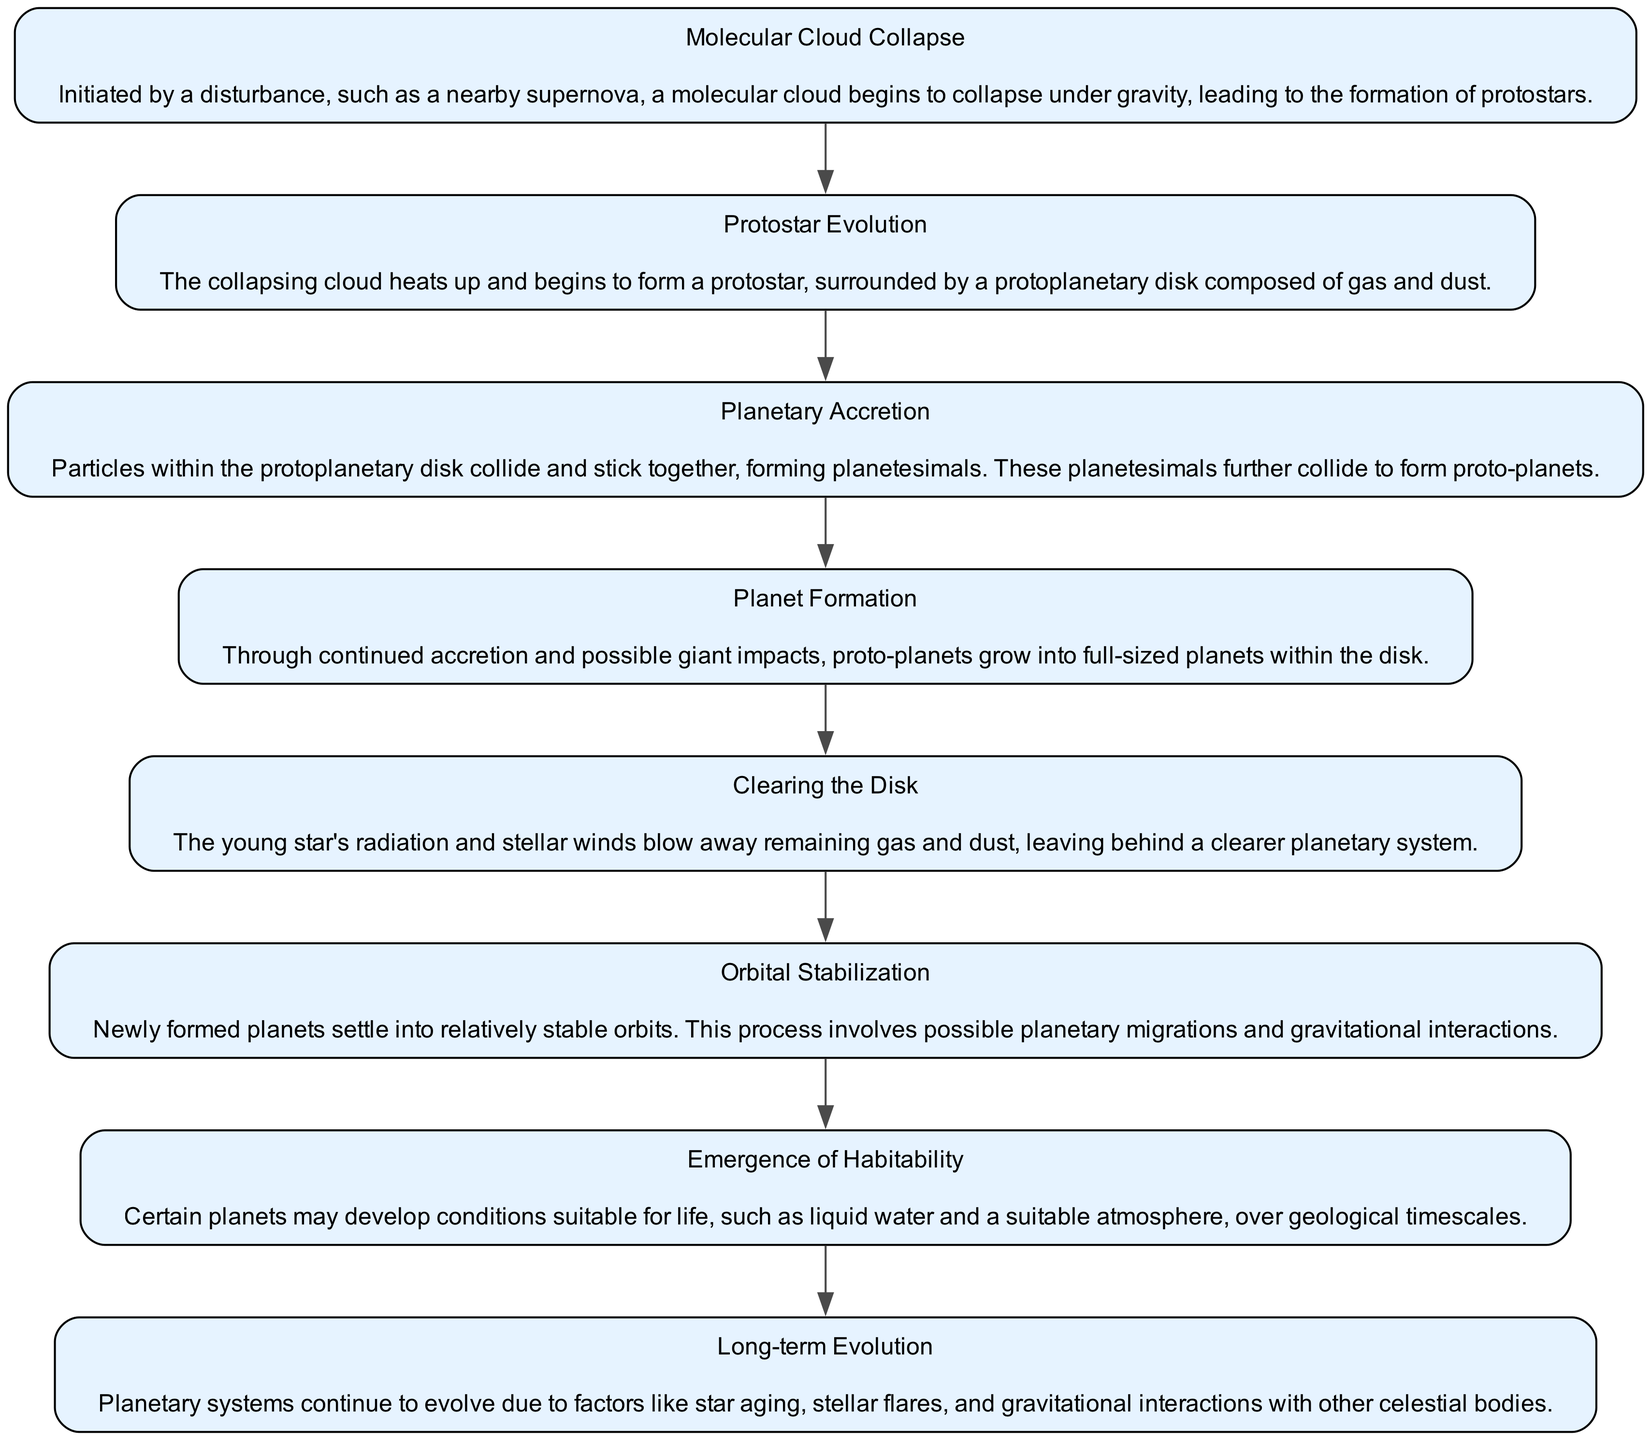What is the first step in the lifecycle of a planetary system? The first step in the lifecycle is "Molecular Cloud Collapse", which is initiated by a disturbance leading to the formation of protostars.
Answer: Molecular Cloud Collapse How many nodes are there in the diagram? Counting all the steps from "Molecular Cloud Collapse" to "Long-term Evolution" gives us a total of eight distinct nodes in the diagram.
Answer: Eight What process follows planetary accretion? After planetary accretion, the next step is "Planet Formation", where proto-planets grow into full-sized planets.
Answer: Planet Formation What is cleared by stellar winds according to the diagram? The description indicates that "Clearing the Disk" is the process where stellar winds blow away remaining gas and dust in the protoplanetary disk.
Answer: Remaining gas and dust Which step involves planetary migrations? The "Orbital Stabilization" step includes the process where newly formed planets settle into stable orbits, which involves planetary migrations.
Answer: Orbital Stabilization What aspect does the "Emergence of Habitability" focus on? This step focuses on the development of conditions suitable for life, such as liquid water and atmospheric conditions, over geological timescales.
Answer: Conditions suitable for life Which nodes are connected directly by an edge to "Planet Formation"? "Planetary Accretion" directly connects to "Planet Formation" as the step before it, and subsequently, "Clearing the Disk" is the next step after "Planet Formation".
Answer: Planetary Accretion and Clearing the Disk Which process involves gravitational interactions with other celestial bodies? The step titled "Long-term Evolution" discusses how planetary systems evolve due to factors including gravitational interactions with other celestial bodies.
Answer: Long-term Evolution 